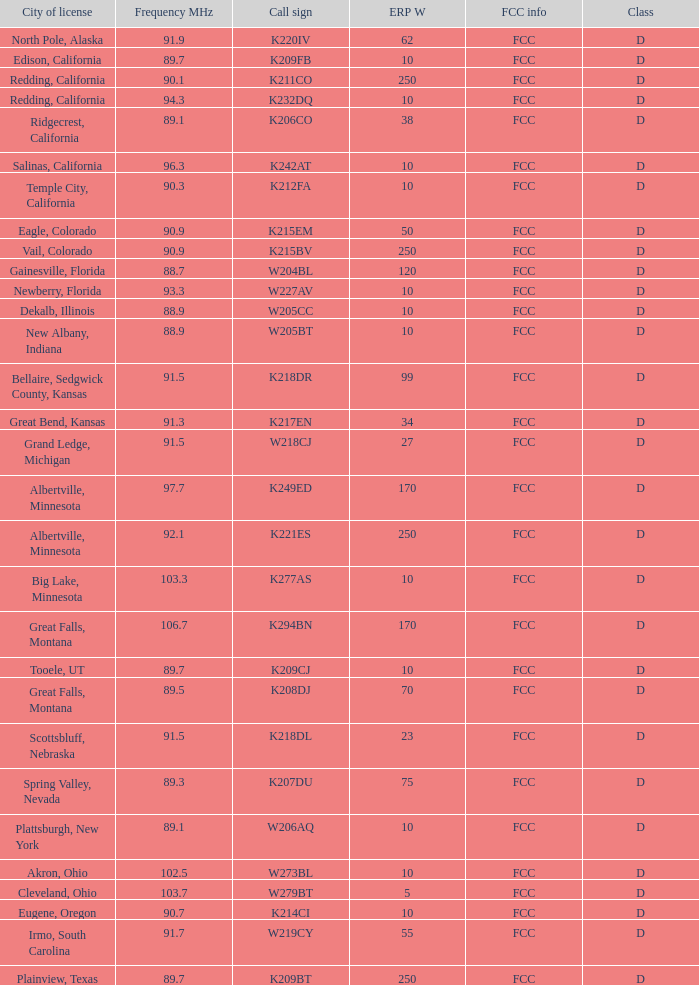What is the class of the translator with 10 ERP W and a call sign of w273bl? D. 